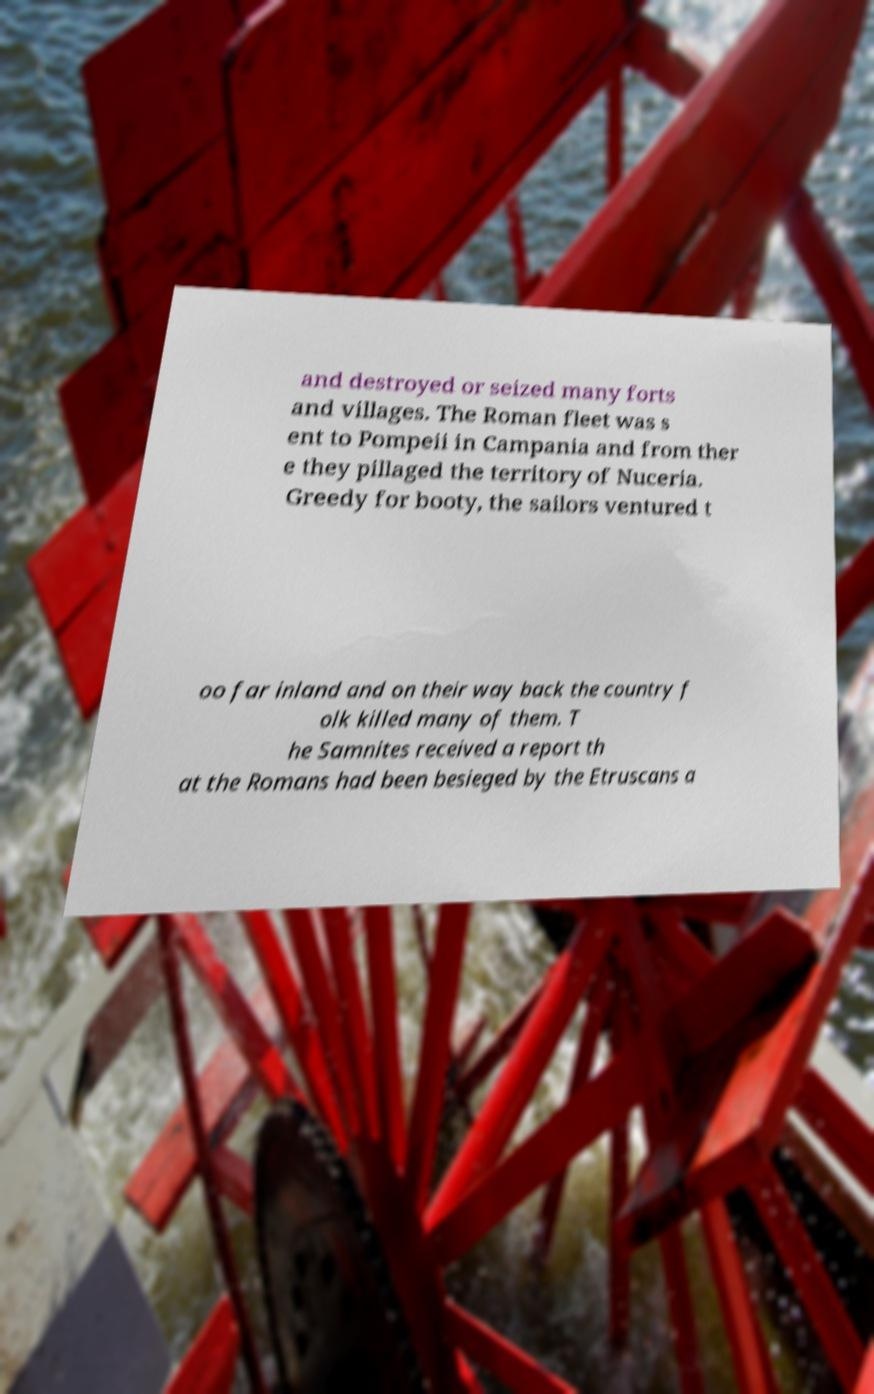Please identify and transcribe the text found in this image. and destroyed or seized many forts and villages. The Roman fleet was s ent to Pompeii in Campania and from ther e they pillaged the territory of Nuceria. Greedy for booty, the sailors ventured t oo far inland and on their way back the country f olk killed many of them. T he Samnites received a report th at the Romans had been besieged by the Etruscans a 